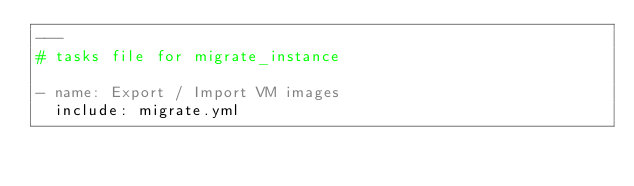Convert code to text. <code><loc_0><loc_0><loc_500><loc_500><_YAML_>---
# tasks file for migrate_instance

- name: Export / Import VM images
  include: migrate.yml</code> 